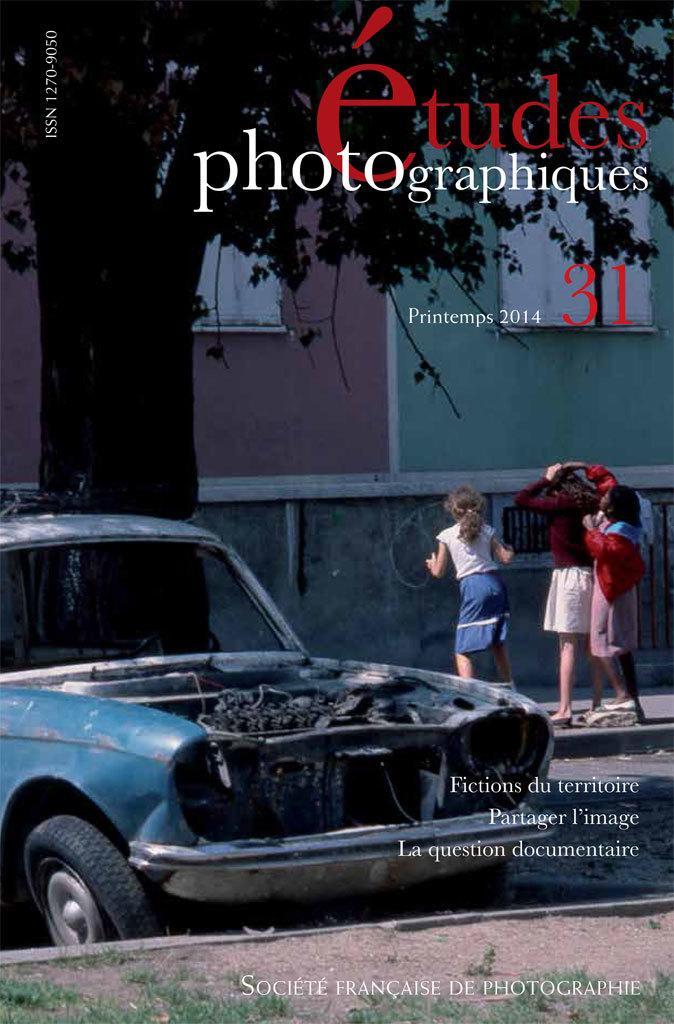How would you summarize this image in a sentence or two? In this image we can see a picture of a group of people standing on the ground. In the foreground we can see a car parked on the road and some grass. In the background, we can see a building with windows and a tree. In the bottom we can see some text. 